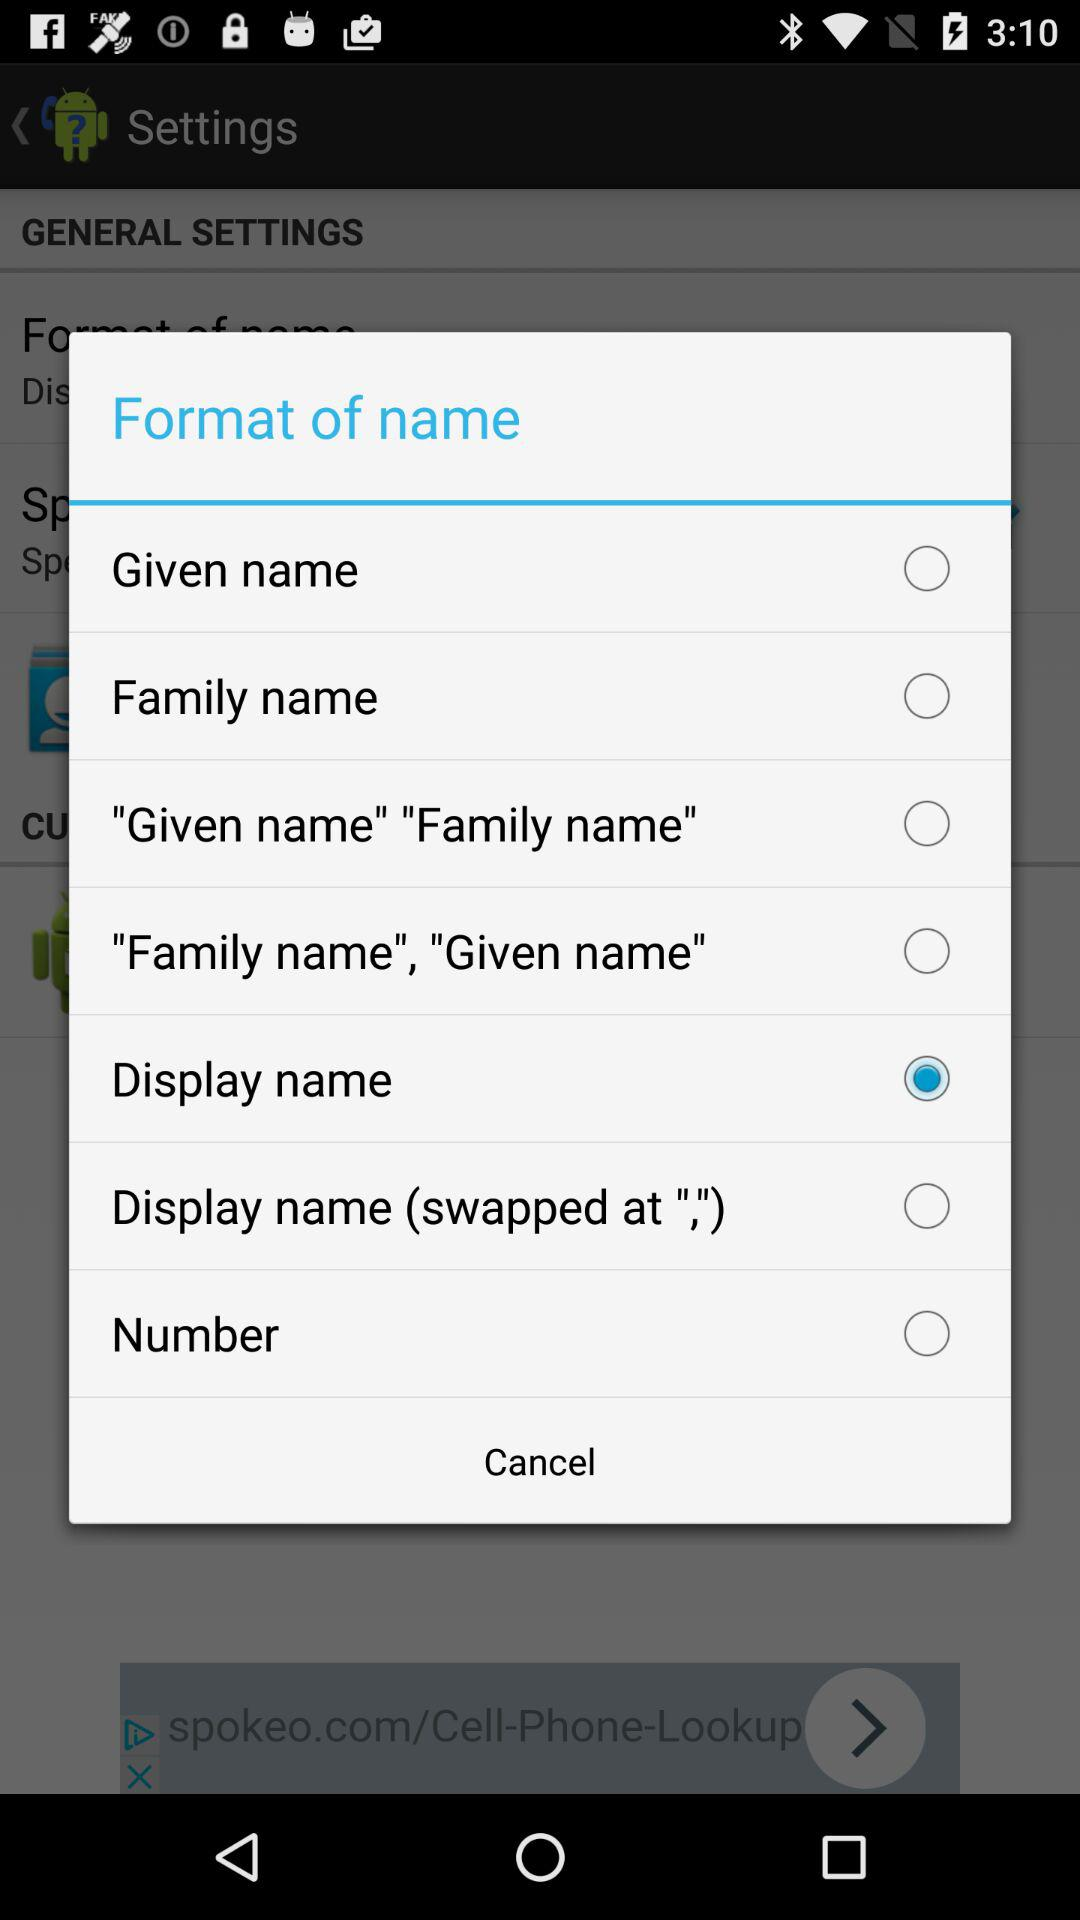Which is the selected "Format of name" from various options? The selected option is "Display name". 